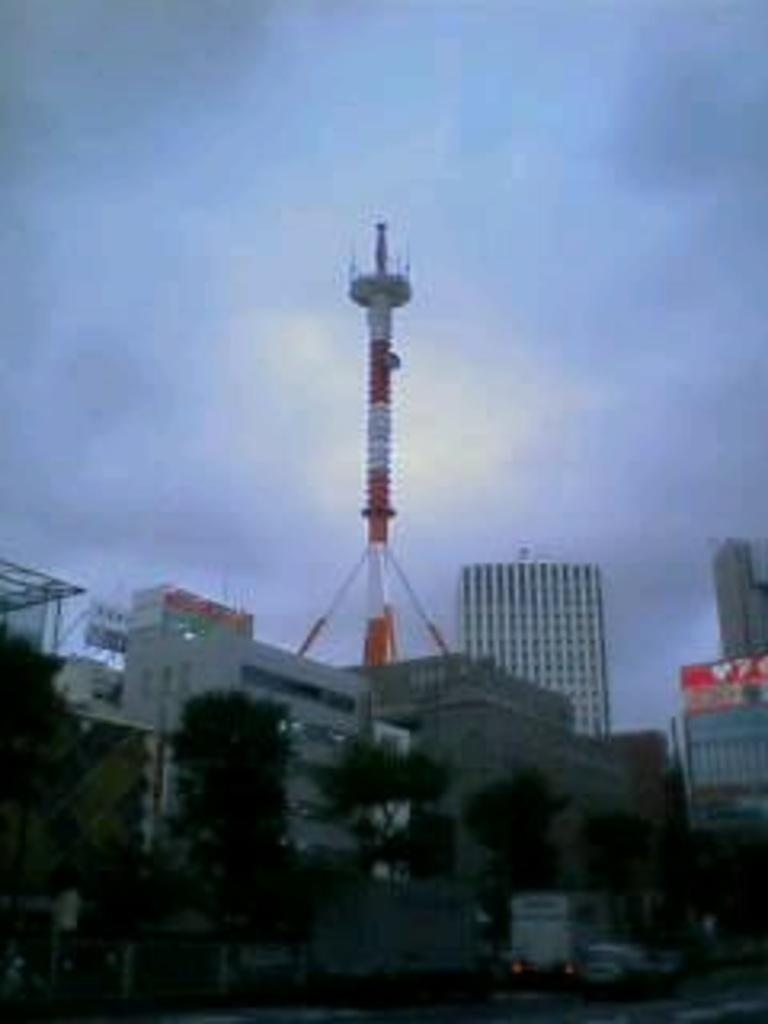What type of structures can be seen in the image? There are buildings and a tower in the image. What other objects or features can be seen in the image? There are trees, vehicles, and the sky visible in the image. Can you describe the tower in the image? The tower is a tall structure that stands out among the other buildings. What is visible in the background of the image? The sky is visible in the background of the image. How does the gate open in the image? There is no gate present in the image. What type of attention is the tower receiving in the image? The tower is not receiving any specific attention in the image; it is simply one of the structures present. 